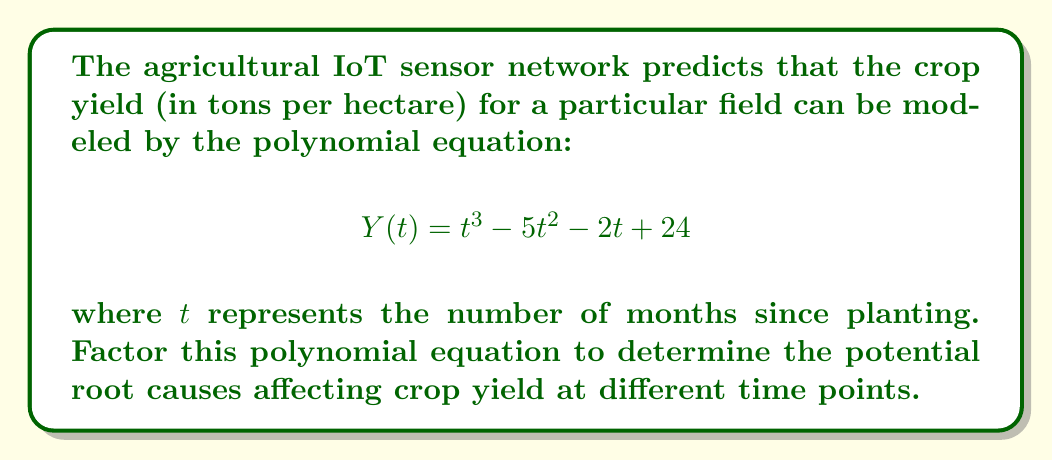Could you help me with this problem? To factor this polynomial, we'll follow these steps:

1) First, let's check if there are any common factors. In this case, there are none.

2) Next, we'll try to guess one root. By the rational root theorem, possible roots are factors of the constant term (24). Let's try some: ±1, ±2, ±3, ±4, ±6, ±8, ±12, ±24.

   Testing $t = 3$: $3^3 - 5(3)^2 - 2(3) + 24 = 27 - 45 - 6 + 24 = 0$

   So, $(t - 3)$ is a factor.

3) Divide the original polynomial by $(t - 3)$:

   $$\frac{t^3 - 5t^2 - 2t + 24}{t - 3} = t^2 - 2t - 8$$

4) Now we have: $Y(t) = (t - 3)(t^2 - 2t - 8)$

5) The quadratic factor $t^2 - 2t - 8$ can be factored further:

   $t^2 - 2t - 8 = (t - 4)(t + 2)$

6) Therefore, the final factored form is:

   $$Y(t) = (t - 3)(t - 4)(t + 2)$$

This factorization reveals that the crop yield could be zero (i.e., crop failure) at 3 months and 4 months after planting, and theoretically at -2 months (which isn't practically meaningful but could represent pre-planting conditions).
Answer: $$Y(t) = (t - 3)(t - 4)(t + 2)$$ 